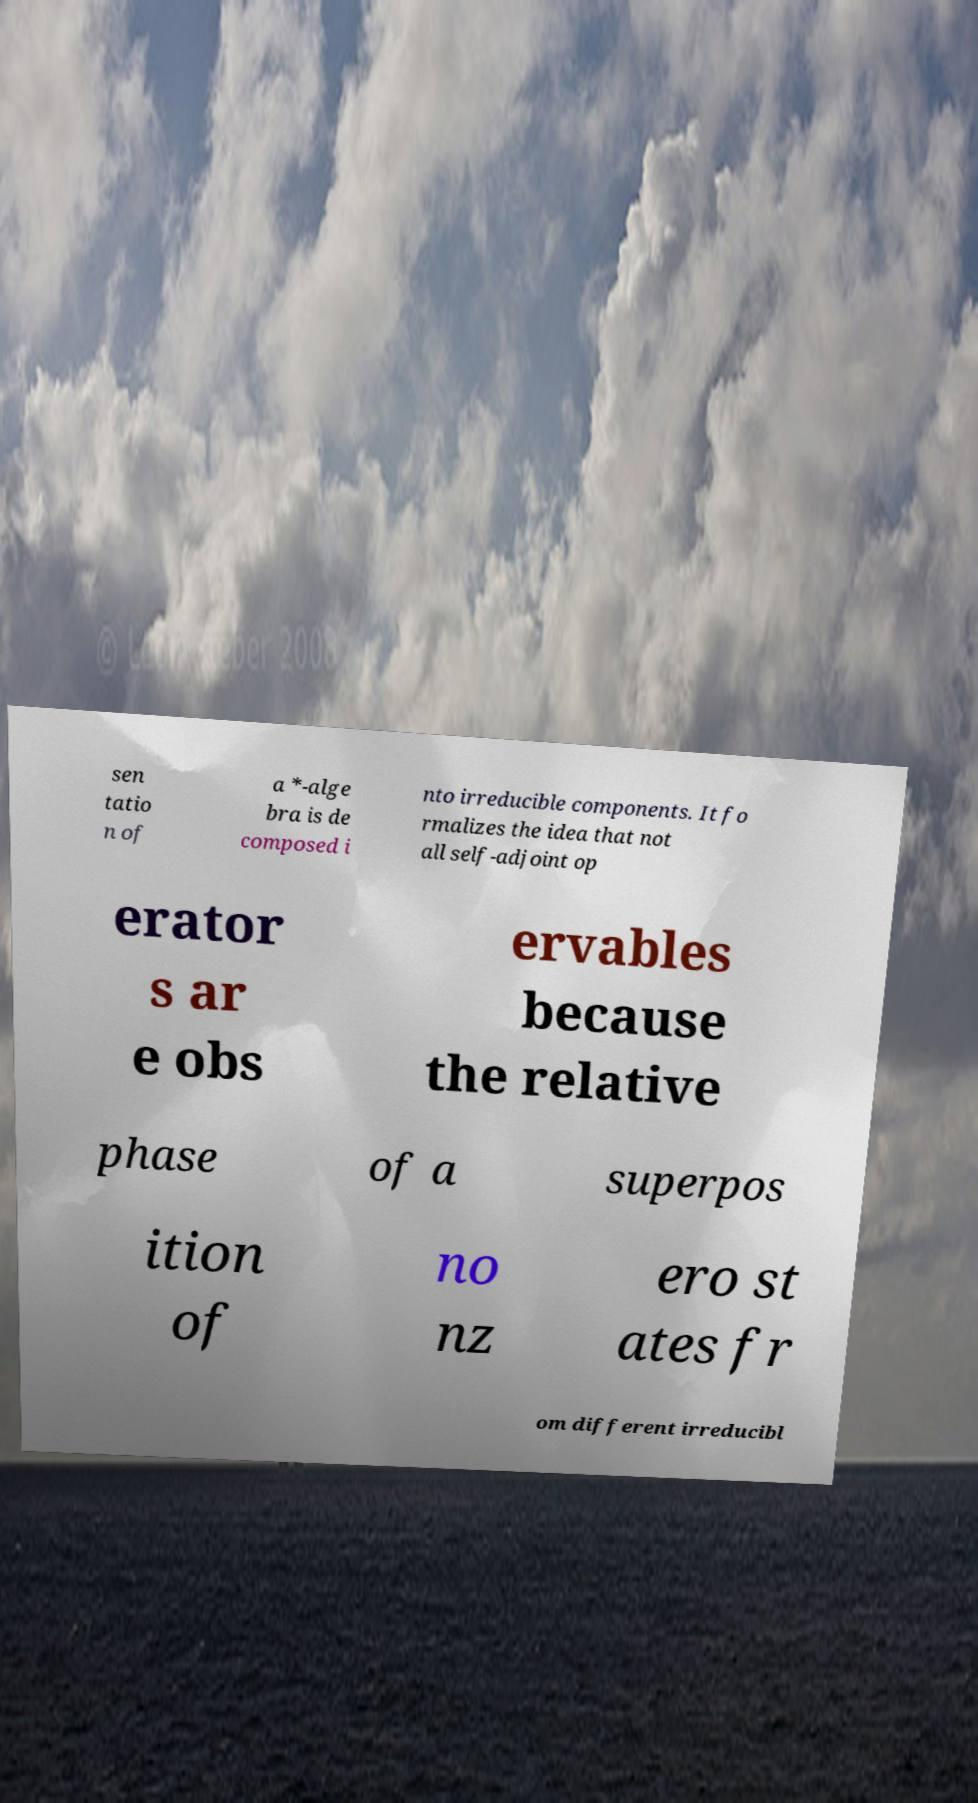Can you accurately transcribe the text from the provided image for me? sen tatio n of a *-alge bra is de composed i nto irreducible components. It fo rmalizes the idea that not all self-adjoint op erator s ar e obs ervables because the relative phase of a superpos ition of no nz ero st ates fr om different irreducibl 